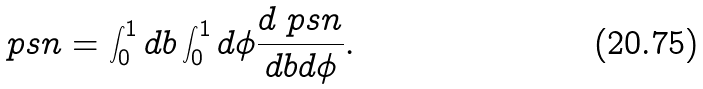<formula> <loc_0><loc_0><loc_500><loc_500>\ p s n = \int _ { 0 } ^ { 1 } d b \int _ { 0 } ^ { 1 } d \phi \frac { d \ p s n } { d b d \phi } .</formula> 